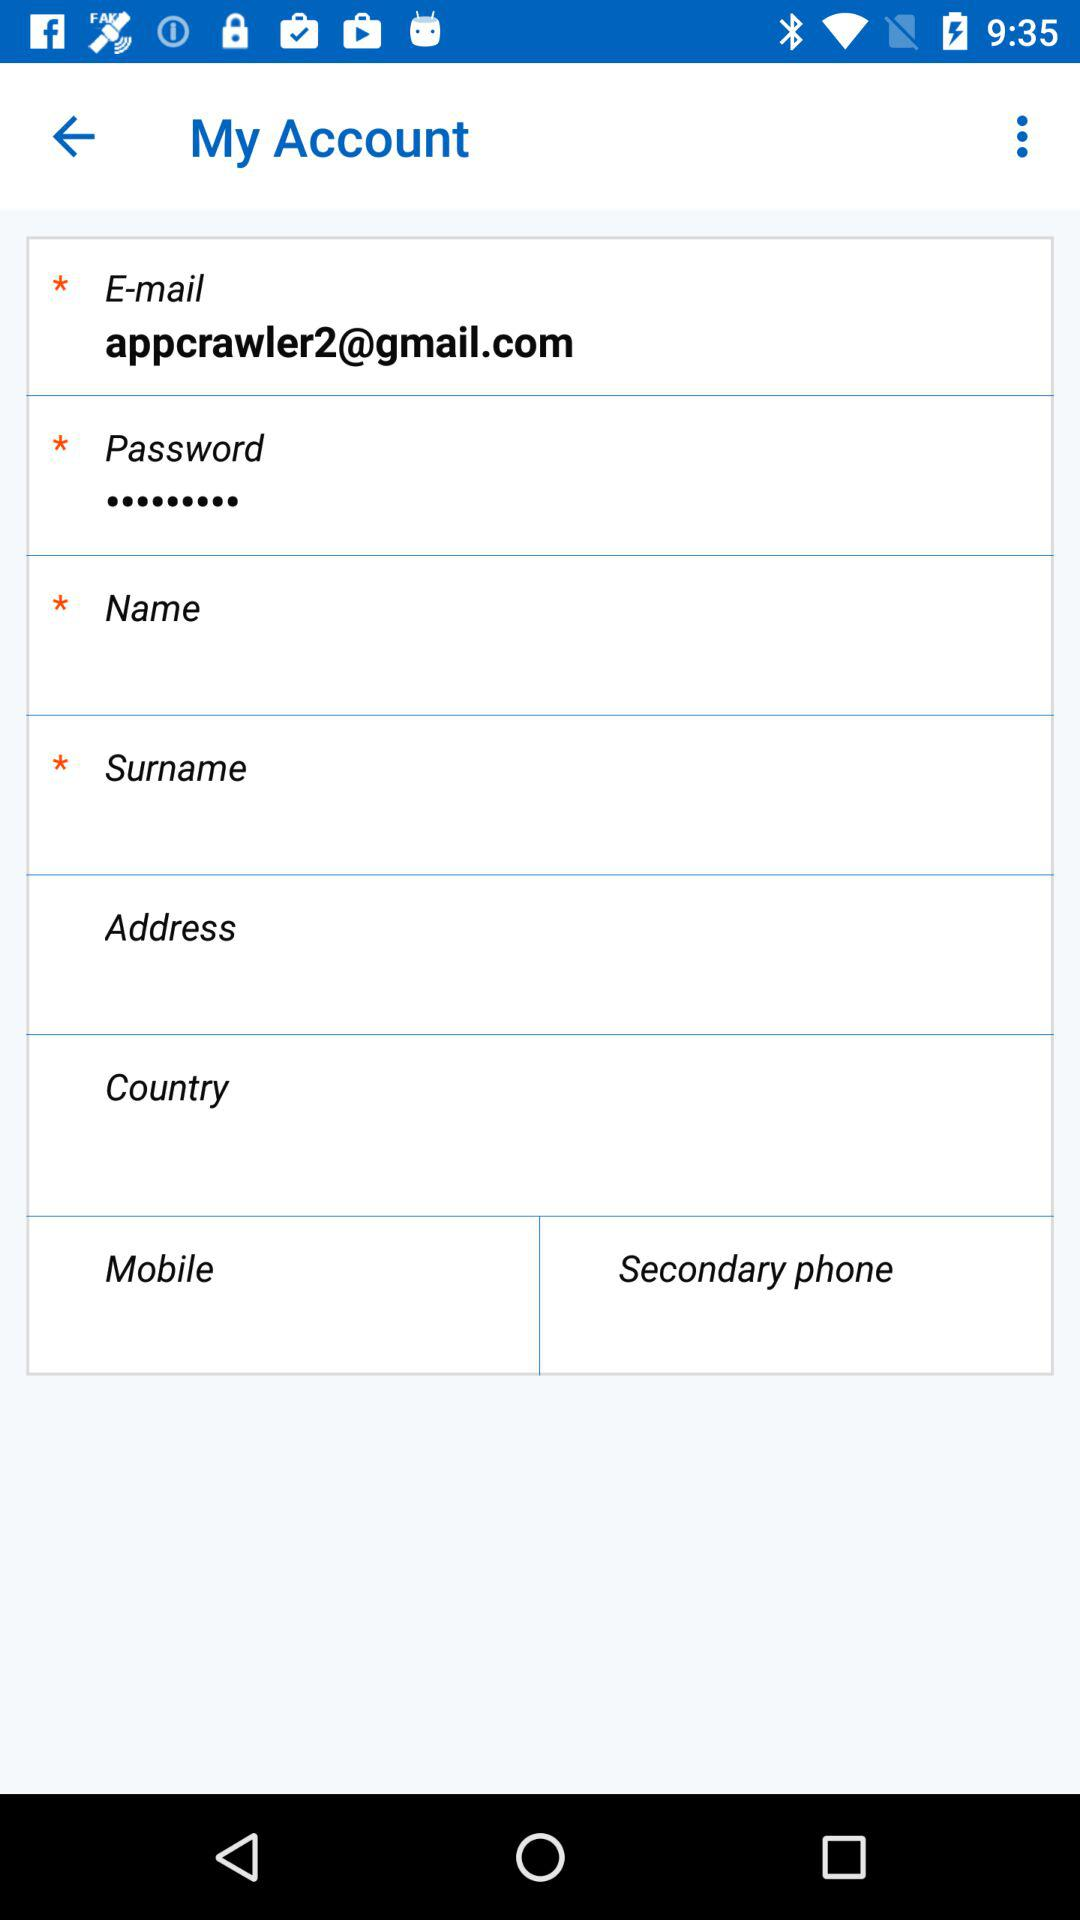What is the surname?
When the provided information is insufficient, respond with <no answer>. <no answer> 